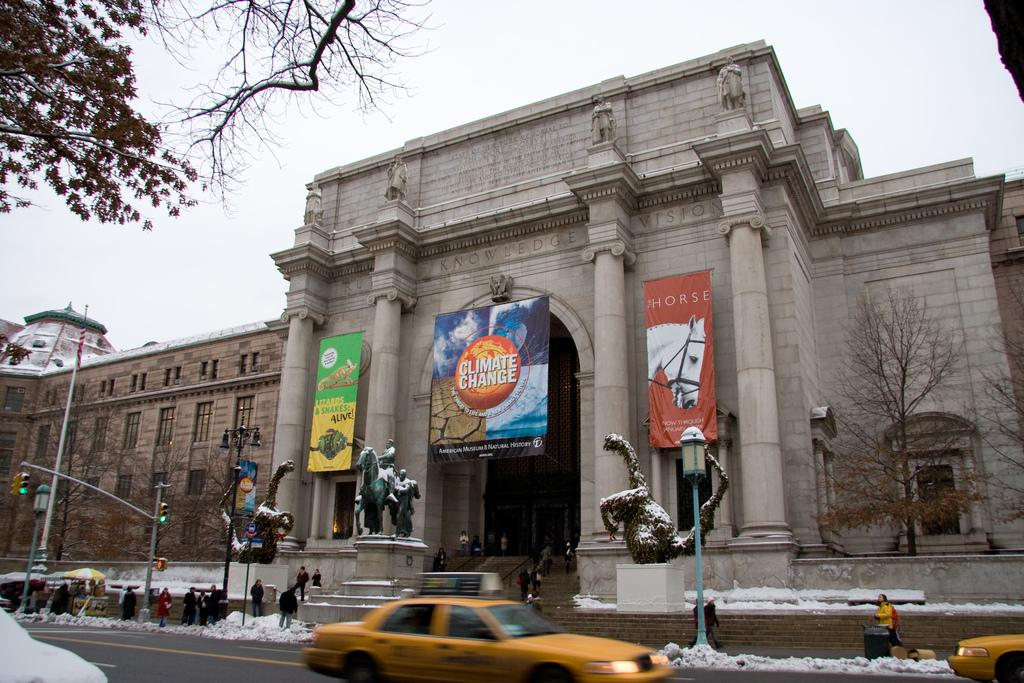<image>
Render a clear and concise summary of the photo. a poster with the word climate change on it 